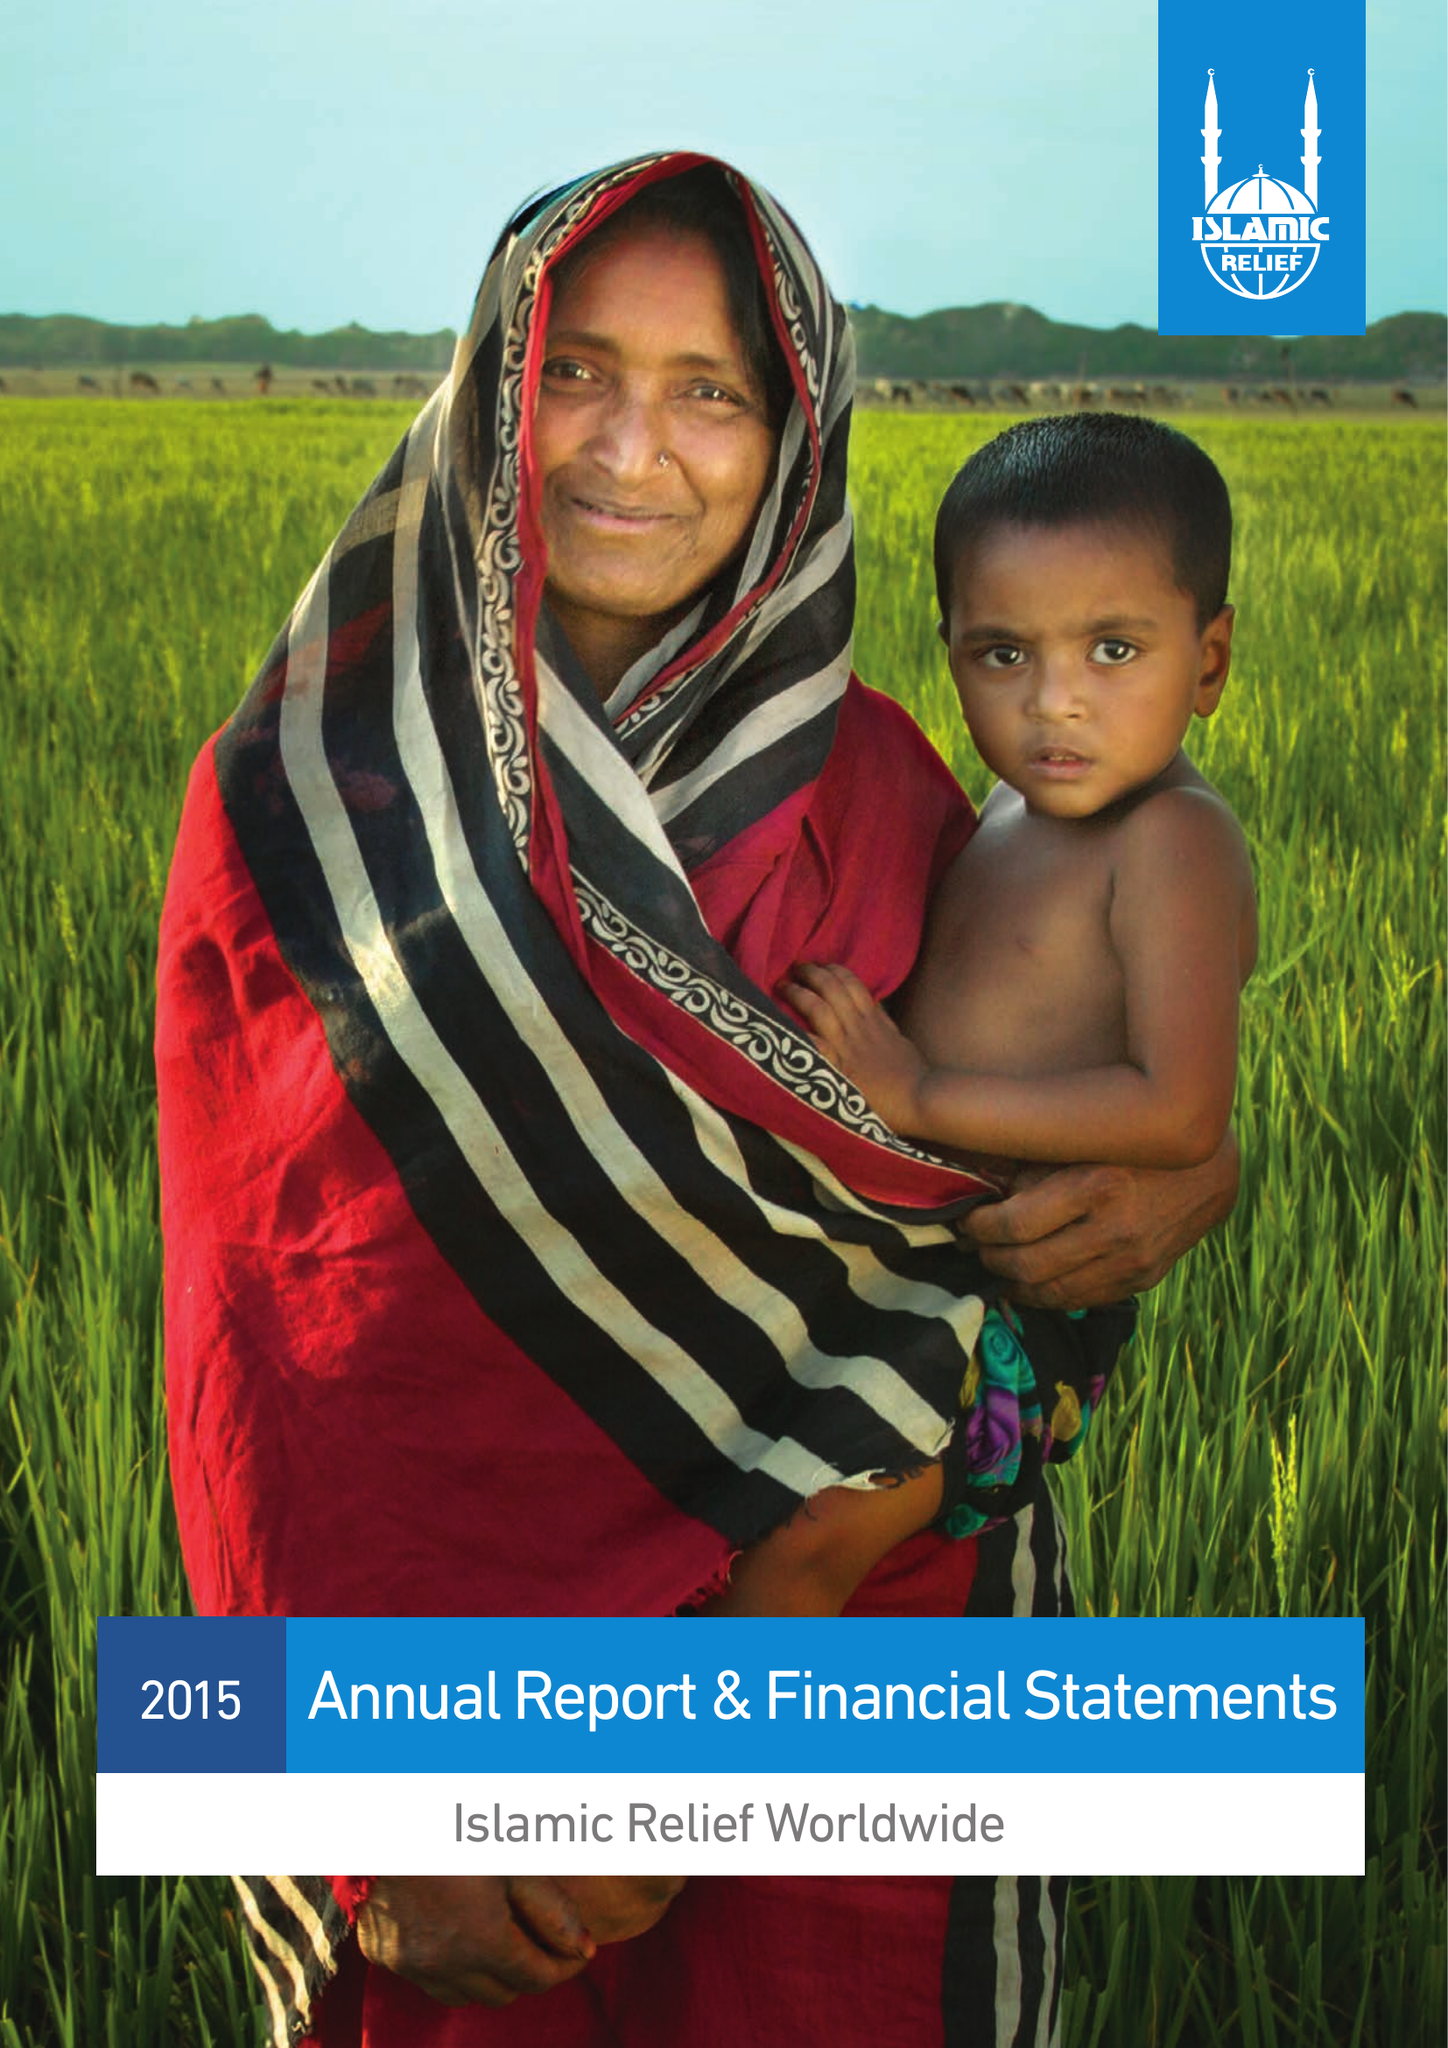What is the value for the address__post_town?
Answer the question using a single word or phrase. BIRMINGHAM 